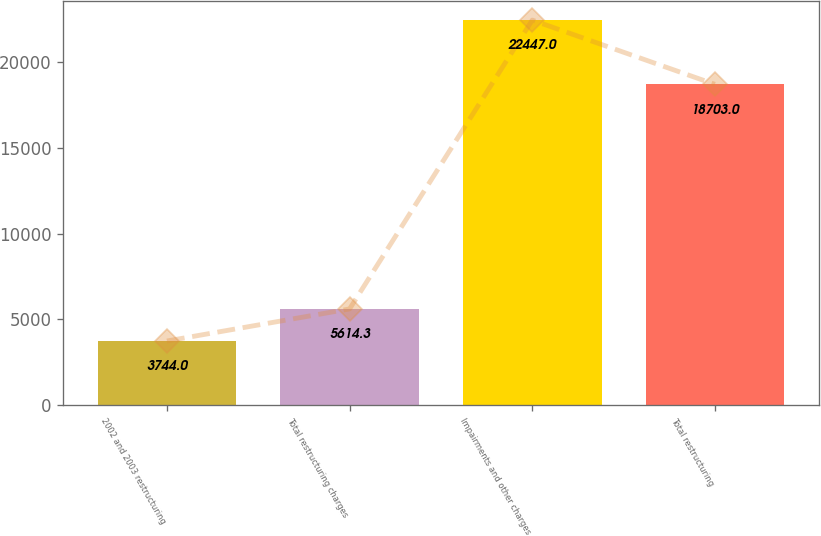<chart> <loc_0><loc_0><loc_500><loc_500><bar_chart><fcel>2002 and 2003 restructuring<fcel>Total restructuring charges<fcel>Impairments and other charges<fcel>Total restructuring<nl><fcel>3744<fcel>5614.3<fcel>22447<fcel>18703<nl></chart> 